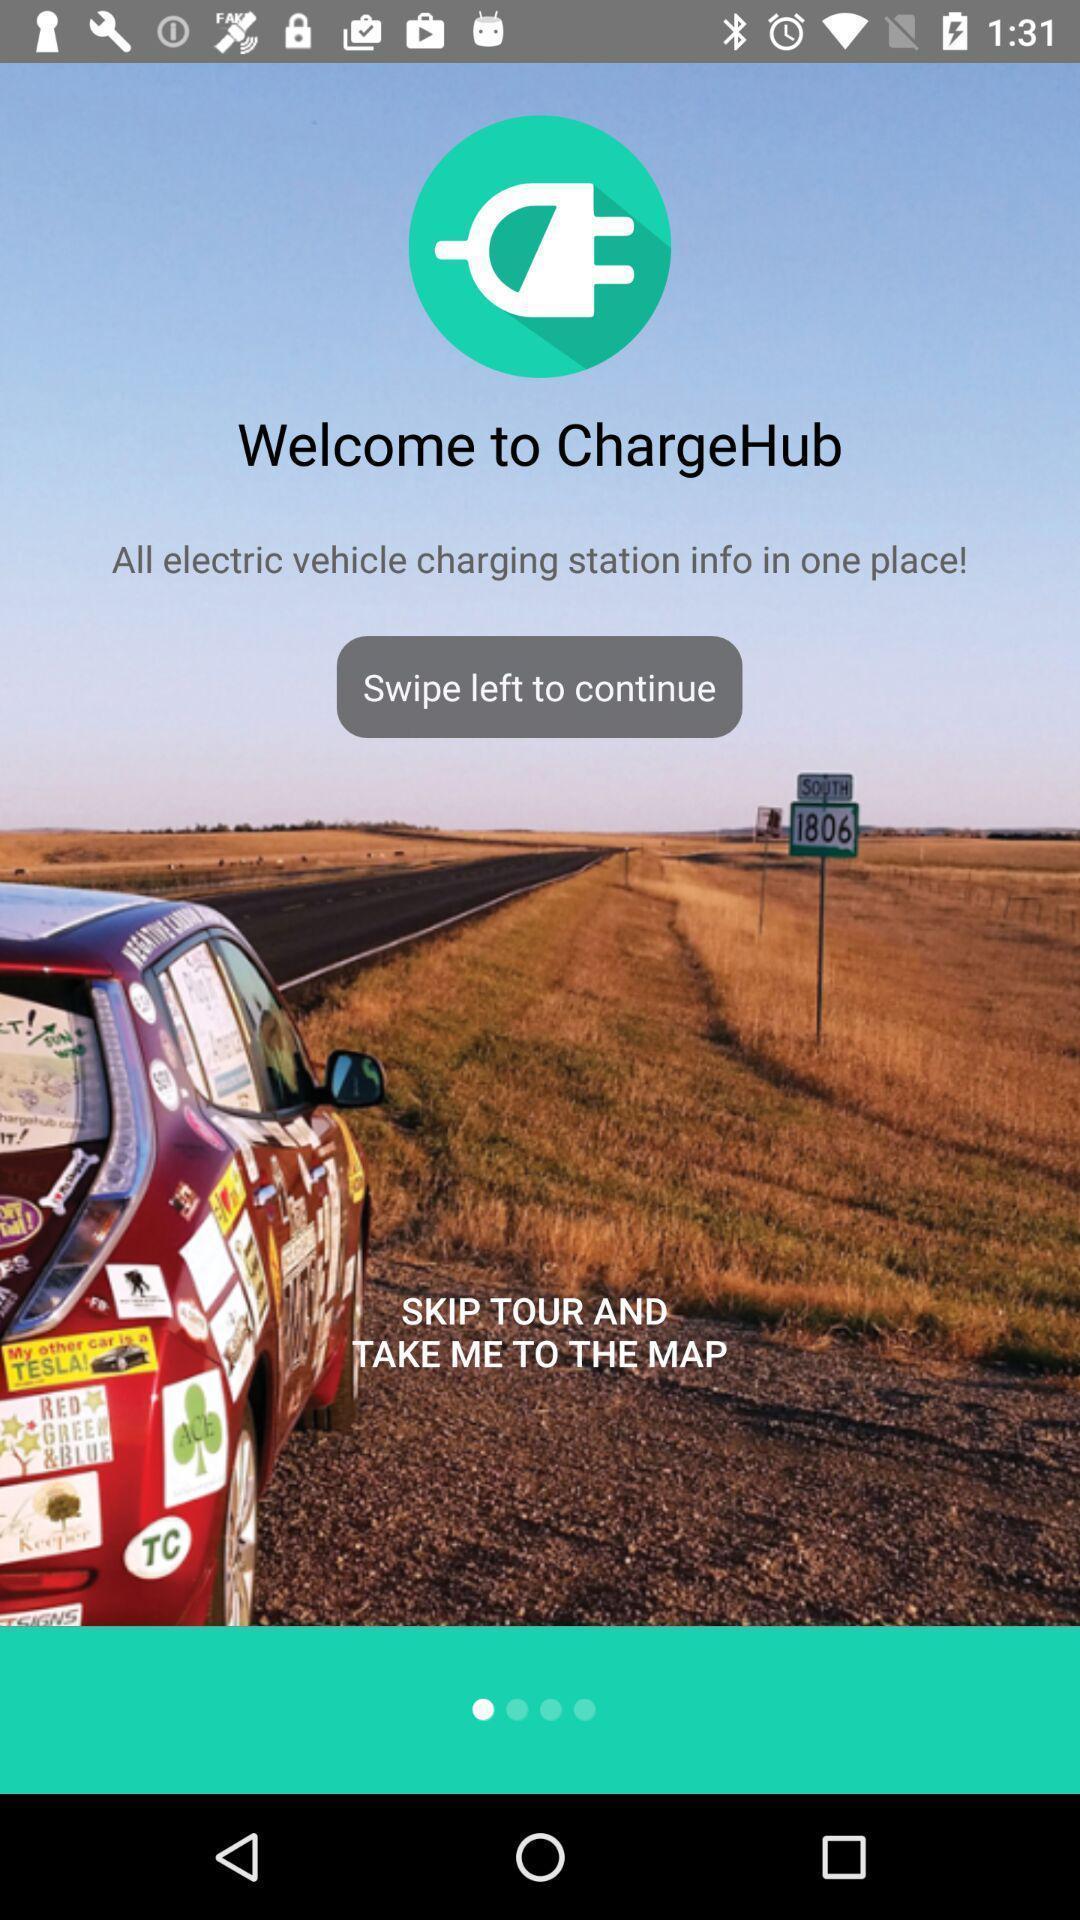Describe this image in words. Welcome page. 